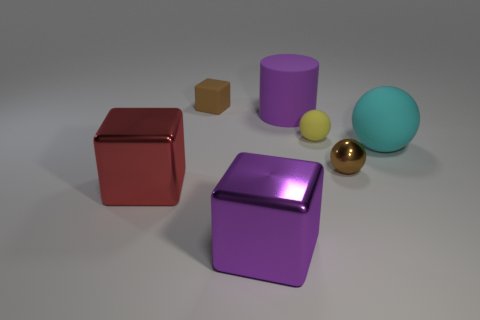Add 3 big blue rubber spheres. How many objects exist? 10 Subtract all blocks. How many objects are left? 4 Subtract 0 cyan cubes. How many objects are left? 7 Subtract all large purple metal objects. Subtract all big cyan rubber cubes. How many objects are left? 6 Add 7 tiny matte balls. How many tiny matte balls are left? 8 Add 1 small yellow rubber things. How many small yellow rubber things exist? 2 